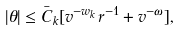<formula> <loc_0><loc_0><loc_500><loc_500>| \theta | \leq \bar { C } _ { k } [ v ^ { - w _ { k } } r ^ { - 1 } + v ^ { - \omega } ] ,</formula> 